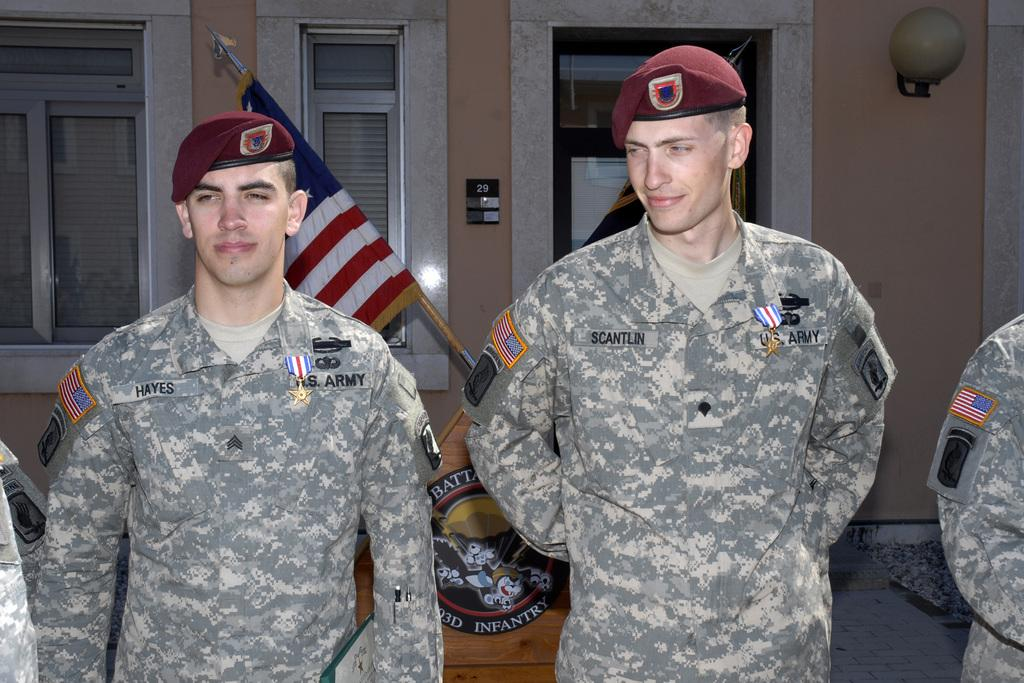<image>
Create a compact narrative representing the image presented. Two U.S. Army soldiers stand next to each other. 